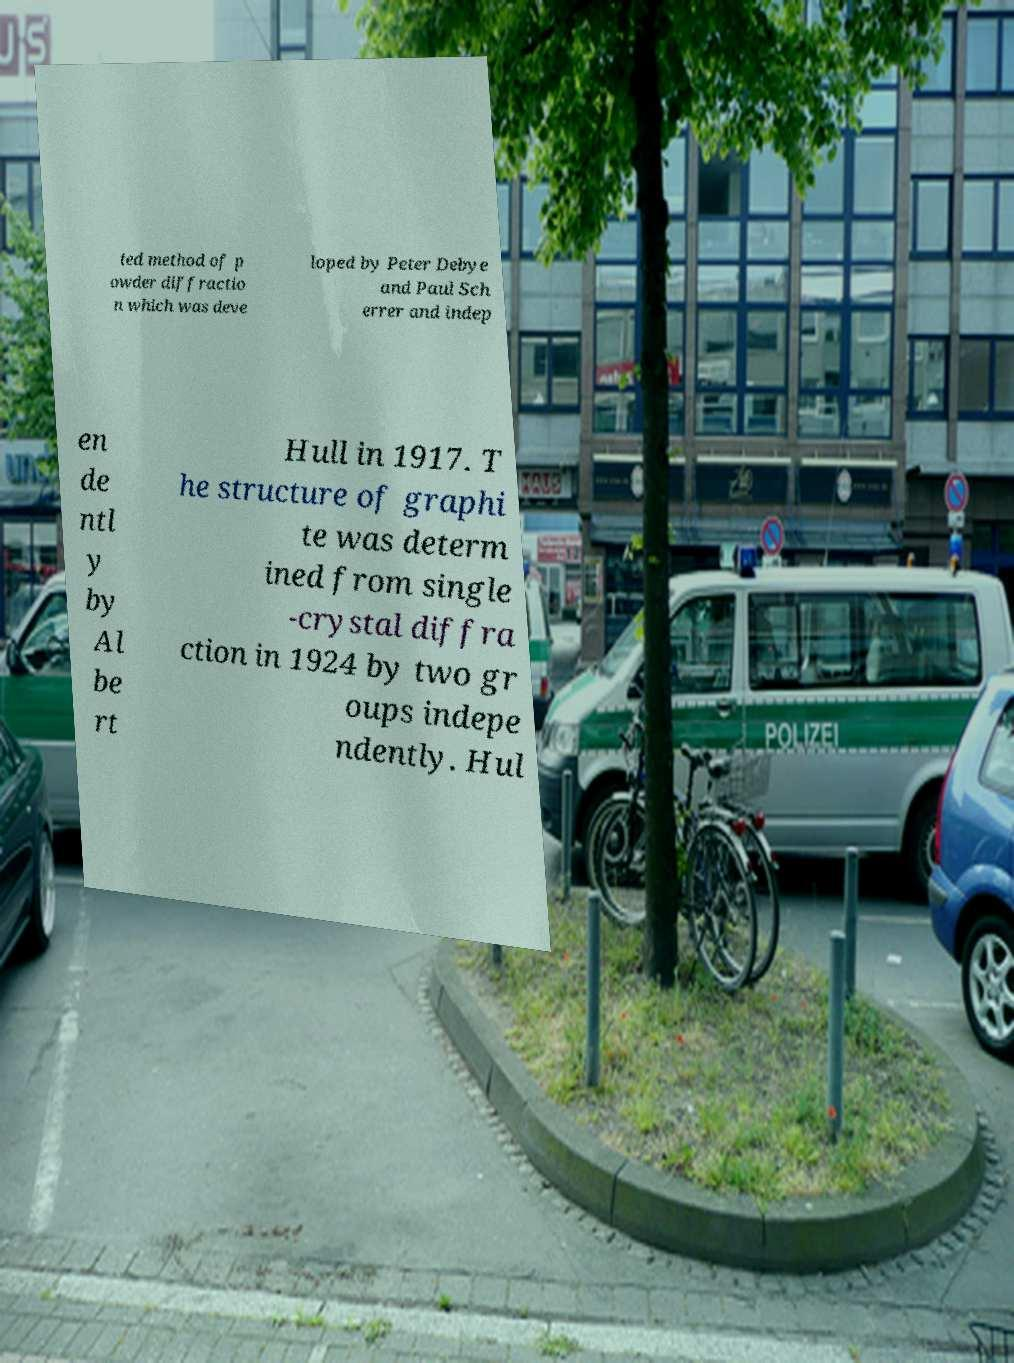For documentation purposes, I need the text within this image transcribed. Could you provide that? ted method of p owder diffractio n which was deve loped by Peter Debye and Paul Sch errer and indep en de ntl y by Al be rt Hull in 1917. T he structure of graphi te was determ ined from single -crystal diffra ction in 1924 by two gr oups indepe ndently. Hul 